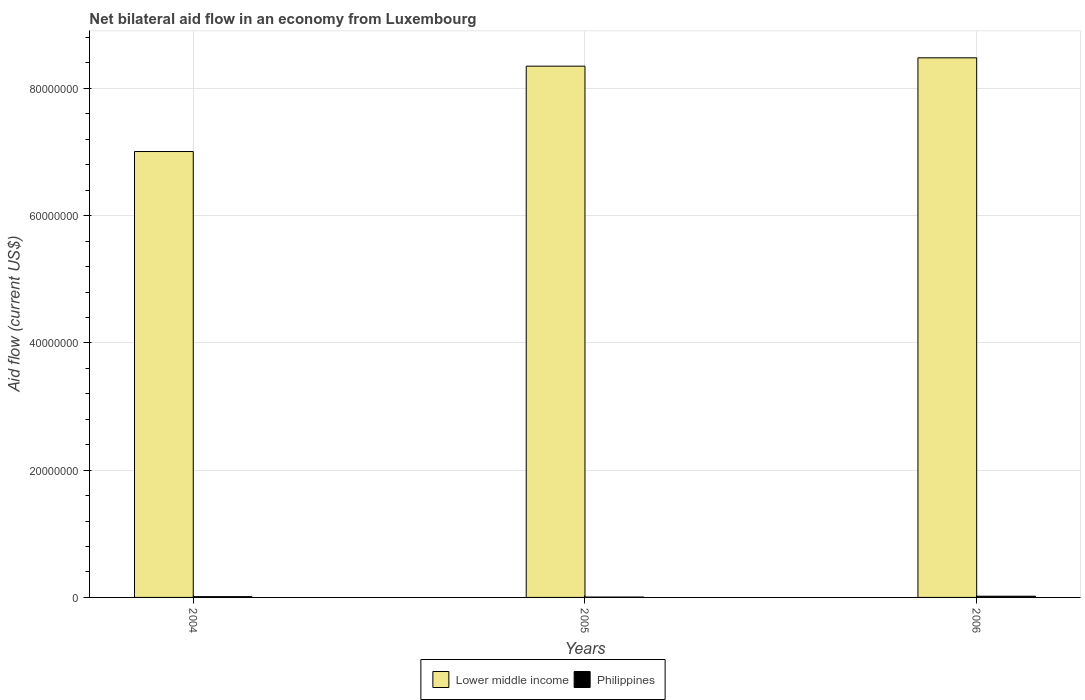How many different coloured bars are there?
Your answer should be compact. 2. Are the number of bars per tick equal to the number of legend labels?
Offer a very short reply. Yes. How many bars are there on the 3rd tick from the left?
Keep it short and to the point. 2. How many bars are there on the 2nd tick from the right?
Make the answer very short. 2. What is the label of the 1st group of bars from the left?
Provide a succinct answer. 2004. What is the net bilateral aid flow in Lower middle income in 2005?
Keep it short and to the point. 8.35e+07. Across all years, what is the maximum net bilateral aid flow in Lower middle income?
Provide a succinct answer. 8.48e+07. In which year was the net bilateral aid flow in Philippines minimum?
Give a very brief answer. 2005. What is the total net bilateral aid flow in Lower middle income in the graph?
Your answer should be compact. 2.38e+08. What is the difference between the net bilateral aid flow in Lower middle income in 2005 and the net bilateral aid flow in Philippines in 2006?
Your response must be concise. 8.33e+07. What is the average net bilateral aid flow in Lower middle income per year?
Make the answer very short. 7.95e+07. In the year 2004, what is the difference between the net bilateral aid flow in Philippines and net bilateral aid flow in Lower middle income?
Give a very brief answer. -7.00e+07. What is the ratio of the net bilateral aid flow in Philippines in 2004 to that in 2006?
Offer a very short reply. 0.63. Is the difference between the net bilateral aid flow in Philippines in 2004 and 2005 greater than the difference between the net bilateral aid flow in Lower middle income in 2004 and 2005?
Your answer should be compact. Yes. What is the difference between the highest and the second highest net bilateral aid flow in Lower middle income?
Give a very brief answer. 1.31e+06. What is the difference between the highest and the lowest net bilateral aid flow in Lower middle income?
Keep it short and to the point. 1.47e+07. Is the sum of the net bilateral aid flow in Philippines in 2005 and 2006 greater than the maximum net bilateral aid flow in Lower middle income across all years?
Provide a succinct answer. No. What does the 2nd bar from the left in 2005 represents?
Your response must be concise. Philippines. How many bars are there?
Make the answer very short. 6. Does the graph contain any zero values?
Provide a short and direct response. No. Does the graph contain grids?
Provide a succinct answer. Yes. How many legend labels are there?
Ensure brevity in your answer.  2. How are the legend labels stacked?
Your response must be concise. Horizontal. What is the title of the graph?
Keep it short and to the point. Net bilateral aid flow in an economy from Luxembourg. What is the label or title of the X-axis?
Your response must be concise. Years. What is the Aid flow (current US$) of Lower middle income in 2004?
Make the answer very short. 7.01e+07. What is the Aid flow (current US$) of Philippines in 2004?
Offer a terse response. 1.20e+05. What is the Aid flow (current US$) of Lower middle income in 2005?
Offer a terse response. 8.35e+07. What is the Aid flow (current US$) of Philippines in 2005?
Provide a succinct answer. 6.00e+04. What is the Aid flow (current US$) of Lower middle income in 2006?
Your response must be concise. 8.48e+07. What is the Aid flow (current US$) in Philippines in 2006?
Your answer should be compact. 1.90e+05. Across all years, what is the maximum Aid flow (current US$) in Lower middle income?
Offer a very short reply. 8.48e+07. Across all years, what is the maximum Aid flow (current US$) in Philippines?
Ensure brevity in your answer.  1.90e+05. Across all years, what is the minimum Aid flow (current US$) in Lower middle income?
Your answer should be very brief. 7.01e+07. Across all years, what is the minimum Aid flow (current US$) of Philippines?
Ensure brevity in your answer.  6.00e+04. What is the total Aid flow (current US$) in Lower middle income in the graph?
Your answer should be very brief. 2.38e+08. What is the difference between the Aid flow (current US$) of Lower middle income in 2004 and that in 2005?
Your answer should be very brief. -1.34e+07. What is the difference between the Aid flow (current US$) of Philippines in 2004 and that in 2005?
Your answer should be very brief. 6.00e+04. What is the difference between the Aid flow (current US$) of Lower middle income in 2004 and that in 2006?
Provide a short and direct response. -1.47e+07. What is the difference between the Aid flow (current US$) of Lower middle income in 2005 and that in 2006?
Your response must be concise. -1.31e+06. What is the difference between the Aid flow (current US$) in Philippines in 2005 and that in 2006?
Make the answer very short. -1.30e+05. What is the difference between the Aid flow (current US$) in Lower middle income in 2004 and the Aid flow (current US$) in Philippines in 2005?
Offer a very short reply. 7.00e+07. What is the difference between the Aid flow (current US$) in Lower middle income in 2004 and the Aid flow (current US$) in Philippines in 2006?
Your answer should be compact. 6.99e+07. What is the difference between the Aid flow (current US$) of Lower middle income in 2005 and the Aid flow (current US$) of Philippines in 2006?
Give a very brief answer. 8.33e+07. What is the average Aid flow (current US$) of Lower middle income per year?
Offer a very short reply. 7.95e+07. What is the average Aid flow (current US$) of Philippines per year?
Offer a very short reply. 1.23e+05. In the year 2004, what is the difference between the Aid flow (current US$) of Lower middle income and Aid flow (current US$) of Philippines?
Provide a short and direct response. 7.00e+07. In the year 2005, what is the difference between the Aid flow (current US$) in Lower middle income and Aid flow (current US$) in Philippines?
Your answer should be compact. 8.34e+07. In the year 2006, what is the difference between the Aid flow (current US$) in Lower middle income and Aid flow (current US$) in Philippines?
Make the answer very short. 8.46e+07. What is the ratio of the Aid flow (current US$) of Lower middle income in 2004 to that in 2005?
Give a very brief answer. 0.84. What is the ratio of the Aid flow (current US$) in Lower middle income in 2004 to that in 2006?
Ensure brevity in your answer.  0.83. What is the ratio of the Aid flow (current US$) in Philippines in 2004 to that in 2006?
Your answer should be compact. 0.63. What is the ratio of the Aid flow (current US$) of Lower middle income in 2005 to that in 2006?
Provide a succinct answer. 0.98. What is the ratio of the Aid flow (current US$) in Philippines in 2005 to that in 2006?
Ensure brevity in your answer.  0.32. What is the difference between the highest and the second highest Aid flow (current US$) in Lower middle income?
Ensure brevity in your answer.  1.31e+06. What is the difference between the highest and the lowest Aid flow (current US$) of Lower middle income?
Ensure brevity in your answer.  1.47e+07. 